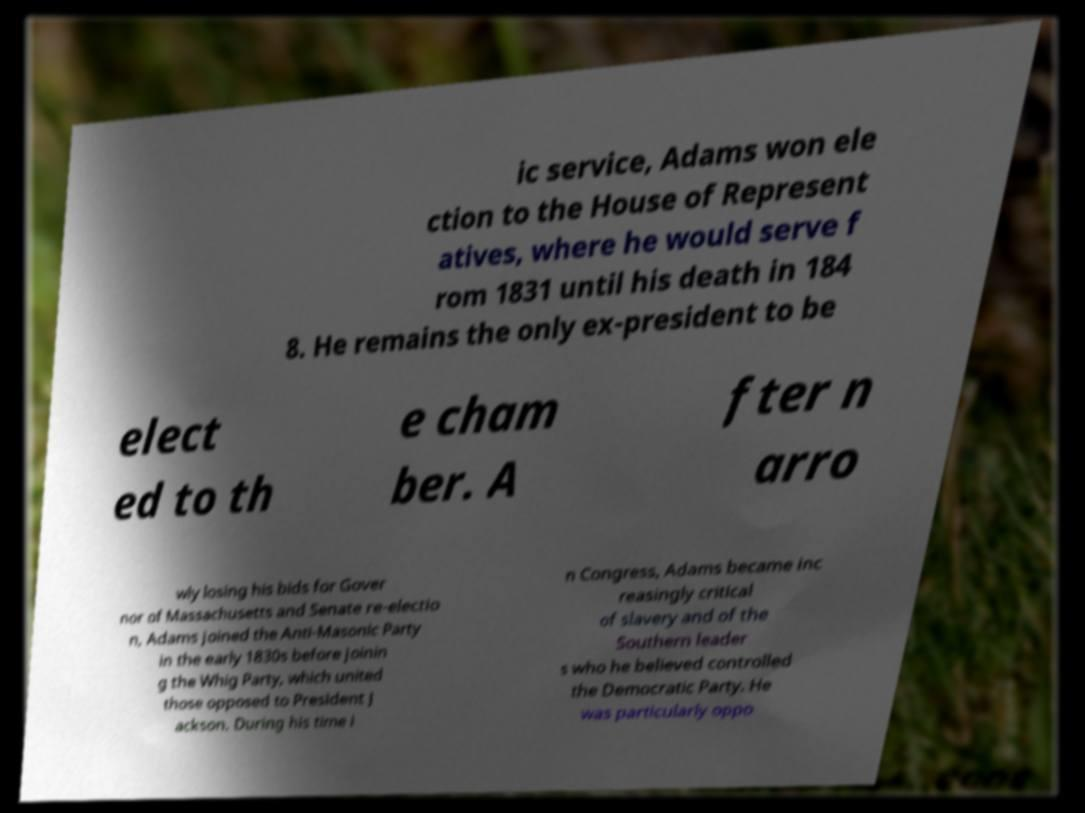For documentation purposes, I need the text within this image transcribed. Could you provide that? ic service, Adams won ele ction to the House of Represent atives, where he would serve f rom 1831 until his death in 184 8. He remains the only ex-president to be elect ed to th e cham ber. A fter n arro wly losing his bids for Gover nor of Massachusetts and Senate re-electio n, Adams joined the Anti-Masonic Party in the early 1830s before joinin g the Whig Party, which united those opposed to President J ackson. During his time i n Congress, Adams became inc reasingly critical of slavery and of the Southern leader s who he believed controlled the Democratic Party. He was particularly oppo 